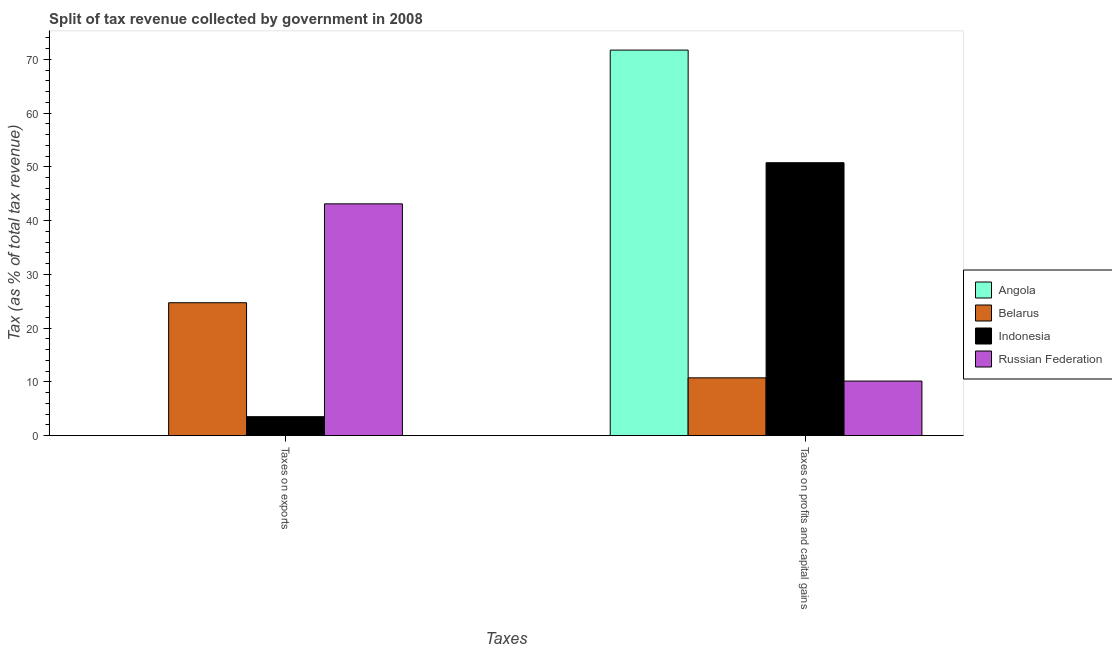What is the label of the 2nd group of bars from the left?
Your response must be concise. Taxes on profits and capital gains. What is the percentage of revenue obtained from taxes on exports in Angola?
Offer a very short reply. 0. Across all countries, what is the maximum percentage of revenue obtained from taxes on profits and capital gains?
Your answer should be very brief. 71.74. Across all countries, what is the minimum percentage of revenue obtained from taxes on profits and capital gains?
Provide a short and direct response. 10.16. In which country was the percentage of revenue obtained from taxes on exports maximum?
Your answer should be compact. Russian Federation. In which country was the percentage of revenue obtained from taxes on profits and capital gains minimum?
Provide a short and direct response. Russian Federation. What is the total percentage of revenue obtained from taxes on exports in the graph?
Your answer should be compact. 71.4. What is the difference between the percentage of revenue obtained from taxes on profits and capital gains in Indonesia and that in Russian Federation?
Offer a terse response. 40.63. What is the difference between the percentage of revenue obtained from taxes on profits and capital gains in Belarus and the percentage of revenue obtained from taxes on exports in Russian Federation?
Give a very brief answer. -32.38. What is the average percentage of revenue obtained from taxes on profits and capital gains per country?
Keep it short and to the point. 35.86. What is the difference between the percentage of revenue obtained from taxes on exports and percentage of revenue obtained from taxes on profits and capital gains in Belarus?
Offer a terse response. 13.98. What is the ratio of the percentage of revenue obtained from taxes on exports in Indonesia to that in Russian Federation?
Keep it short and to the point. 0.08. Is the percentage of revenue obtained from taxes on exports in Indonesia less than that in Angola?
Provide a succinct answer. No. What does the 2nd bar from the left in Taxes on exports represents?
Make the answer very short. Belarus. What does the 2nd bar from the right in Taxes on profits and capital gains represents?
Your answer should be very brief. Indonesia. How many bars are there?
Your response must be concise. 8. How many countries are there in the graph?
Keep it short and to the point. 4. Are the values on the major ticks of Y-axis written in scientific E-notation?
Ensure brevity in your answer.  No. Does the graph contain any zero values?
Ensure brevity in your answer.  No. Does the graph contain grids?
Your answer should be very brief. No. Where does the legend appear in the graph?
Your answer should be compact. Center right. What is the title of the graph?
Offer a very short reply. Split of tax revenue collected by government in 2008. What is the label or title of the X-axis?
Give a very brief answer. Taxes. What is the label or title of the Y-axis?
Make the answer very short. Tax (as % of total tax revenue). What is the Tax (as % of total tax revenue) of Angola in Taxes on exports?
Offer a very short reply. 0. What is the Tax (as % of total tax revenue) in Belarus in Taxes on exports?
Make the answer very short. 24.73. What is the Tax (as % of total tax revenue) of Indonesia in Taxes on exports?
Your answer should be very brief. 3.53. What is the Tax (as % of total tax revenue) of Russian Federation in Taxes on exports?
Offer a very short reply. 43.13. What is the Tax (as % of total tax revenue) of Angola in Taxes on profits and capital gains?
Give a very brief answer. 71.74. What is the Tax (as % of total tax revenue) in Belarus in Taxes on profits and capital gains?
Offer a terse response. 10.75. What is the Tax (as % of total tax revenue) of Indonesia in Taxes on profits and capital gains?
Offer a terse response. 50.79. What is the Tax (as % of total tax revenue) in Russian Federation in Taxes on profits and capital gains?
Provide a short and direct response. 10.16. Across all Taxes, what is the maximum Tax (as % of total tax revenue) in Angola?
Make the answer very short. 71.74. Across all Taxes, what is the maximum Tax (as % of total tax revenue) of Belarus?
Offer a very short reply. 24.73. Across all Taxes, what is the maximum Tax (as % of total tax revenue) of Indonesia?
Keep it short and to the point. 50.79. Across all Taxes, what is the maximum Tax (as % of total tax revenue) in Russian Federation?
Offer a terse response. 43.13. Across all Taxes, what is the minimum Tax (as % of total tax revenue) of Angola?
Provide a succinct answer. 0. Across all Taxes, what is the minimum Tax (as % of total tax revenue) of Belarus?
Offer a very short reply. 10.75. Across all Taxes, what is the minimum Tax (as % of total tax revenue) in Indonesia?
Your answer should be compact. 3.53. Across all Taxes, what is the minimum Tax (as % of total tax revenue) of Russian Federation?
Provide a succinct answer. 10.16. What is the total Tax (as % of total tax revenue) in Angola in the graph?
Ensure brevity in your answer.  71.74. What is the total Tax (as % of total tax revenue) of Belarus in the graph?
Give a very brief answer. 35.49. What is the total Tax (as % of total tax revenue) of Indonesia in the graph?
Make the answer very short. 54.32. What is the total Tax (as % of total tax revenue) in Russian Federation in the graph?
Provide a succinct answer. 53.29. What is the difference between the Tax (as % of total tax revenue) of Angola in Taxes on exports and that in Taxes on profits and capital gains?
Your answer should be compact. -71.74. What is the difference between the Tax (as % of total tax revenue) in Belarus in Taxes on exports and that in Taxes on profits and capital gains?
Keep it short and to the point. 13.98. What is the difference between the Tax (as % of total tax revenue) in Indonesia in Taxes on exports and that in Taxes on profits and capital gains?
Your answer should be compact. -47.26. What is the difference between the Tax (as % of total tax revenue) in Russian Federation in Taxes on exports and that in Taxes on profits and capital gains?
Offer a terse response. 32.98. What is the difference between the Tax (as % of total tax revenue) of Angola in Taxes on exports and the Tax (as % of total tax revenue) of Belarus in Taxes on profits and capital gains?
Offer a very short reply. -10.75. What is the difference between the Tax (as % of total tax revenue) in Angola in Taxes on exports and the Tax (as % of total tax revenue) in Indonesia in Taxes on profits and capital gains?
Ensure brevity in your answer.  -50.79. What is the difference between the Tax (as % of total tax revenue) in Angola in Taxes on exports and the Tax (as % of total tax revenue) in Russian Federation in Taxes on profits and capital gains?
Offer a terse response. -10.16. What is the difference between the Tax (as % of total tax revenue) in Belarus in Taxes on exports and the Tax (as % of total tax revenue) in Indonesia in Taxes on profits and capital gains?
Your answer should be very brief. -26.05. What is the difference between the Tax (as % of total tax revenue) in Belarus in Taxes on exports and the Tax (as % of total tax revenue) in Russian Federation in Taxes on profits and capital gains?
Keep it short and to the point. 14.58. What is the difference between the Tax (as % of total tax revenue) in Indonesia in Taxes on exports and the Tax (as % of total tax revenue) in Russian Federation in Taxes on profits and capital gains?
Your answer should be very brief. -6.63. What is the average Tax (as % of total tax revenue) in Angola per Taxes?
Your response must be concise. 35.87. What is the average Tax (as % of total tax revenue) of Belarus per Taxes?
Provide a succinct answer. 17.74. What is the average Tax (as % of total tax revenue) in Indonesia per Taxes?
Your answer should be very brief. 27.16. What is the average Tax (as % of total tax revenue) in Russian Federation per Taxes?
Offer a terse response. 26.64. What is the difference between the Tax (as % of total tax revenue) in Angola and Tax (as % of total tax revenue) in Belarus in Taxes on exports?
Give a very brief answer. -24.73. What is the difference between the Tax (as % of total tax revenue) in Angola and Tax (as % of total tax revenue) in Indonesia in Taxes on exports?
Ensure brevity in your answer.  -3.53. What is the difference between the Tax (as % of total tax revenue) in Angola and Tax (as % of total tax revenue) in Russian Federation in Taxes on exports?
Your answer should be compact. -43.13. What is the difference between the Tax (as % of total tax revenue) in Belarus and Tax (as % of total tax revenue) in Indonesia in Taxes on exports?
Ensure brevity in your answer.  21.21. What is the difference between the Tax (as % of total tax revenue) of Belarus and Tax (as % of total tax revenue) of Russian Federation in Taxes on exports?
Provide a succinct answer. -18.4. What is the difference between the Tax (as % of total tax revenue) of Indonesia and Tax (as % of total tax revenue) of Russian Federation in Taxes on exports?
Your answer should be compact. -39.6. What is the difference between the Tax (as % of total tax revenue) of Angola and Tax (as % of total tax revenue) of Belarus in Taxes on profits and capital gains?
Give a very brief answer. 60.99. What is the difference between the Tax (as % of total tax revenue) in Angola and Tax (as % of total tax revenue) in Indonesia in Taxes on profits and capital gains?
Your answer should be very brief. 20.95. What is the difference between the Tax (as % of total tax revenue) of Angola and Tax (as % of total tax revenue) of Russian Federation in Taxes on profits and capital gains?
Your answer should be compact. 61.59. What is the difference between the Tax (as % of total tax revenue) in Belarus and Tax (as % of total tax revenue) in Indonesia in Taxes on profits and capital gains?
Offer a very short reply. -40.03. What is the difference between the Tax (as % of total tax revenue) in Belarus and Tax (as % of total tax revenue) in Russian Federation in Taxes on profits and capital gains?
Provide a succinct answer. 0.6. What is the difference between the Tax (as % of total tax revenue) in Indonesia and Tax (as % of total tax revenue) in Russian Federation in Taxes on profits and capital gains?
Offer a very short reply. 40.63. What is the ratio of the Tax (as % of total tax revenue) in Angola in Taxes on exports to that in Taxes on profits and capital gains?
Offer a very short reply. 0. What is the ratio of the Tax (as % of total tax revenue) in Belarus in Taxes on exports to that in Taxes on profits and capital gains?
Offer a very short reply. 2.3. What is the ratio of the Tax (as % of total tax revenue) in Indonesia in Taxes on exports to that in Taxes on profits and capital gains?
Make the answer very short. 0.07. What is the ratio of the Tax (as % of total tax revenue) of Russian Federation in Taxes on exports to that in Taxes on profits and capital gains?
Your answer should be compact. 4.25. What is the difference between the highest and the second highest Tax (as % of total tax revenue) in Angola?
Keep it short and to the point. 71.74. What is the difference between the highest and the second highest Tax (as % of total tax revenue) of Belarus?
Provide a succinct answer. 13.98. What is the difference between the highest and the second highest Tax (as % of total tax revenue) in Indonesia?
Provide a short and direct response. 47.26. What is the difference between the highest and the second highest Tax (as % of total tax revenue) of Russian Federation?
Keep it short and to the point. 32.98. What is the difference between the highest and the lowest Tax (as % of total tax revenue) of Angola?
Offer a very short reply. 71.74. What is the difference between the highest and the lowest Tax (as % of total tax revenue) in Belarus?
Offer a terse response. 13.98. What is the difference between the highest and the lowest Tax (as % of total tax revenue) in Indonesia?
Your answer should be very brief. 47.26. What is the difference between the highest and the lowest Tax (as % of total tax revenue) of Russian Federation?
Offer a very short reply. 32.98. 